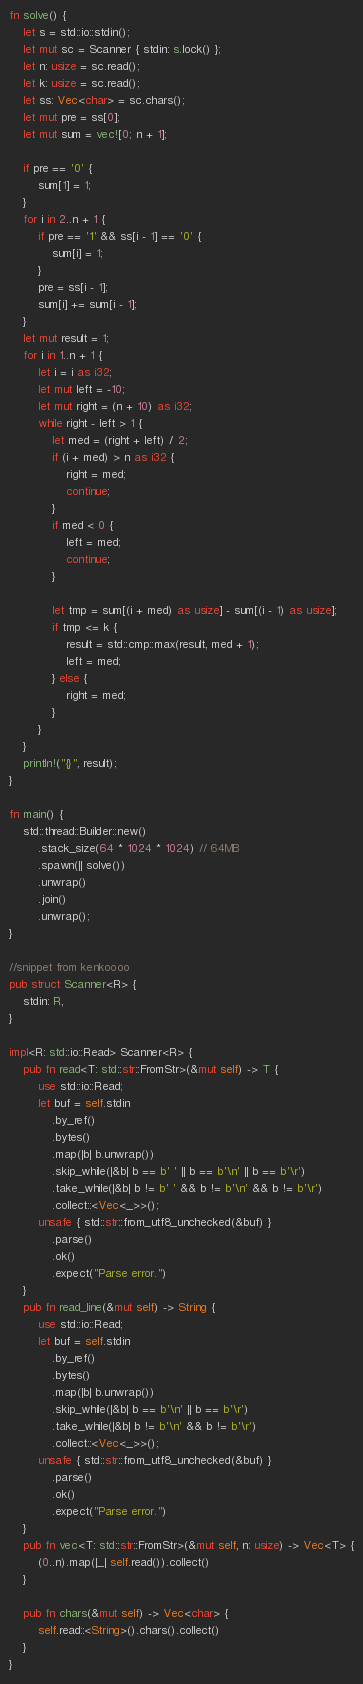Convert code to text. <code><loc_0><loc_0><loc_500><loc_500><_Rust_>fn solve() {
    let s = std::io::stdin();
    let mut sc = Scanner { stdin: s.lock() };
    let n: usize = sc.read();
    let k: usize = sc.read();
    let ss: Vec<char> = sc.chars();
    let mut pre = ss[0];
    let mut sum = vec![0; n + 1];

    if pre == '0' {
        sum[1] = 1;
    }
    for i in 2..n + 1 {
        if pre == '1' && ss[i - 1] == '0' {
            sum[i] = 1;
        }
        pre = ss[i - 1];
        sum[i] += sum[i - 1];
    }
    let mut result = 1;
    for i in 1..n + 1 {
        let i = i as i32;
        let mut left = -10;
        let mut right = (n + 10) as i32;
        while right - left > 1 {
            let med = (right + left) / 2;
            if (i + med) > n as i32 {
                right = med;
                continue;
            }
            if med < 0 {
                left = med;
                continue;
            }

            let tmp = sum[(i + med) as usize] - sum[(i - 1) as usize];
            if tmp <= k {
                result = std::cmp::max(result, med + 1);
                left = med;
            } else {
                right = med;
            }
        }
    }
    println!("{}", result);
}

fn main() {
    std::thread::Builder::new()
        .stack_size(64 * 1024 * 1024) // 64MB
        .spawn(|| solve())
        .unwrap()
        .join()
        .unwrap();
}

//snippet from kenkoooo
pub struct Scanner<R> {
    stdin: R,
}

impl<R: std::io::Read> Scanner<R> {
    pub fn read<T: std::str::FromStr>(&mut self) -> T {
        use std::io::Read;
        let buf = self.stdin
            .by_ref()
            .bytes()
            .map(|b| b.unwrap())
            .skip_while(|&b| b == b' ' || b == b'\n' || b == b'\r')
            .take_while(|&b| b != b' ' && b != b'\n' && b != b'\r')
            .collect::<Vec<_>>();
        unsafe { std::str::from_utf8_unchecked(&buf) }
            .parse()
            .ok()
            .expect("Parse error.")
    }
    pub fn read_line(&mut self) -> String {
        use std::io::Read;
        let buf = self.stdin
            .by_ref()
            .bytes()
            .map(|b| b.unwrap())
            .skip_while(|&b| b == b'\n' || b == b'\r')
            .take_while(|&b| b != b'\n' && b != b'\r')
            .collect::<Vec<_>>();
        unsafe { std::str::from_utf8_unchecked(&buf) }
            .parse()
            .ok()
            .expect("Parse error.")
    }
    pub fn vec<T: std::str::FromStr>(&mut self, n: usize) -> Vec<T> {
        (0..n).map(|_| self.read()).collect()
    }

    pub fn chars(&mut self) -> Vec<char> {
        self.read::<String>().chars().collect()
    }
}
</code> 